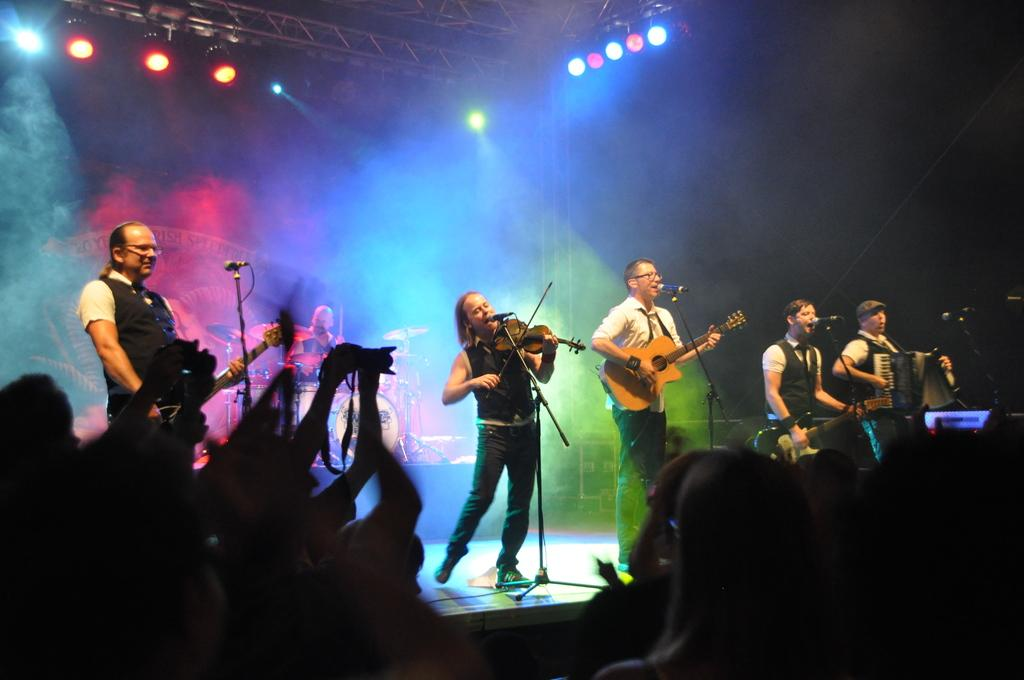How many people are in the image? There are multiple people in the image. What are the people doing in the image? The people are playing musical instruments. What objects are in front of the people? There are microphones in front of the people. What type of hat is the person wearing in the image? There is no hat visible in the image; the people are playing musical instruments and there are microphones in front of them. 